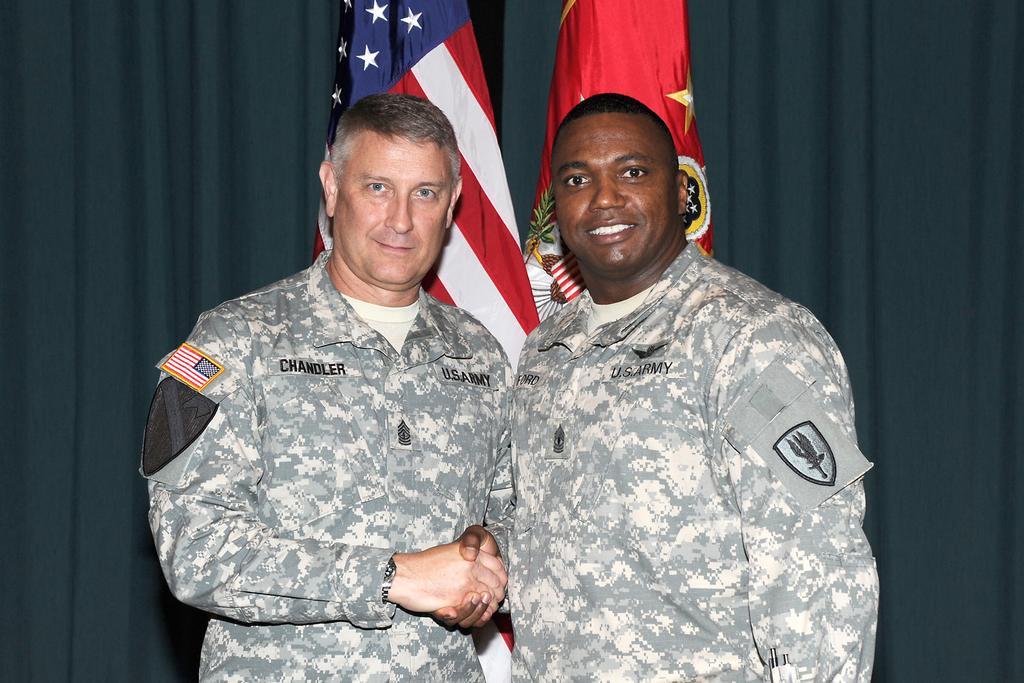Can you describe this image briefly? In this image we can see two people standing and shaking their hands. There are wearing uniforms. In the background there are flags and curtains. 